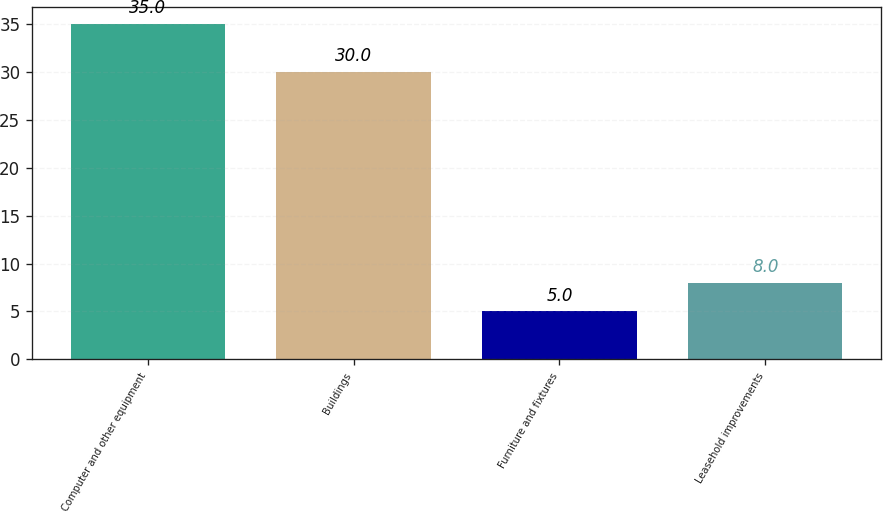<chart> <loc_0><loc_0><loc_500><loc_500><bar_chart><fcel>Computer and other equipment<fcel>Buildings<fcel>Furniture and fixtures<fcel>Leasehold improvements<nl><fcel>35<fcel>30<fcel>5<fcel>8<nl></chart> 